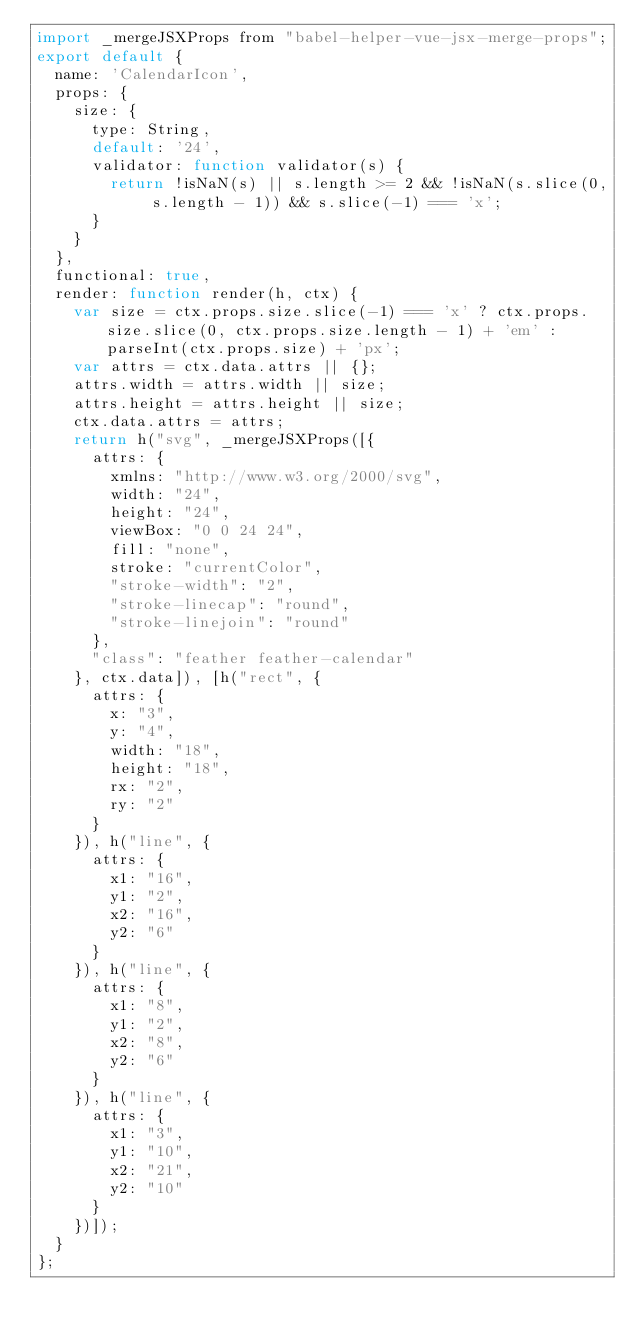<code> <loc_0><loc_0><loc_500><loc_500><_JavaScript_>import _mergeJSXProps from "babel-helper-vue-jsx-merge-props";
export default {
  name: 'CalendarIcon',
  props: {
    size: {
      type: String,
      default: '24',
      validator: function validator(s) {
        return !isNaN(s) || s.length >= 2 && !isNaN(s.slice(0, s.length - 1)) && s.slice(-1) === 'x';
      }
    }
  },
  functional: true,
  render: function render(h, ctx) {
    var size = ctx.props.size.slice(-1) === 'x' ? ctx.props.size.slice(0, ctx.props.size.length - 1) + 'em' : parseInt(ctx.props.size) + 'px';
    var attrs = ctx.data.attrs || {};
    attrs.width = attrs.width || size;
    attrs.height = attrs.height || size;
    ctx.data.attrs = attrs;
    return h("svg", _mergeJSXProps([{
      attrs: {
        xmlns: "http://www.w3.org/2000/svg",
        width: "24",
        height: "24",
        viewBox: "0 0 24 24",
        fill: "none",
        stroke: "currentColor",
        "stroke-width": "2",
        "stroke-linecap": "round",
        "stroke-linejoin": "round"
      },
      "class": "feather feather-calendar"
    }, ctx.data]), [h("rect", {
      attrs: {
        x: "3",
        y: "4",
        width: "18",
        height: "18",
        rx: "2",
        ry: "2"
      }
    }), h("line", {
      attrs: {
        x1: "16",
        y1: "2",
        x2: "16",
        y2: "6"
      }
    }), h("line", {
      attrs: {
        x1: "8",
        y1: "2",
        x2: "8",
        y2: "6"
      }
    }), h("line", {
      attrs: {
        x1: "3",
        y1: "10",
        x2: "21",
        y2: "10"
      }
    })]);
  }
};</code> 